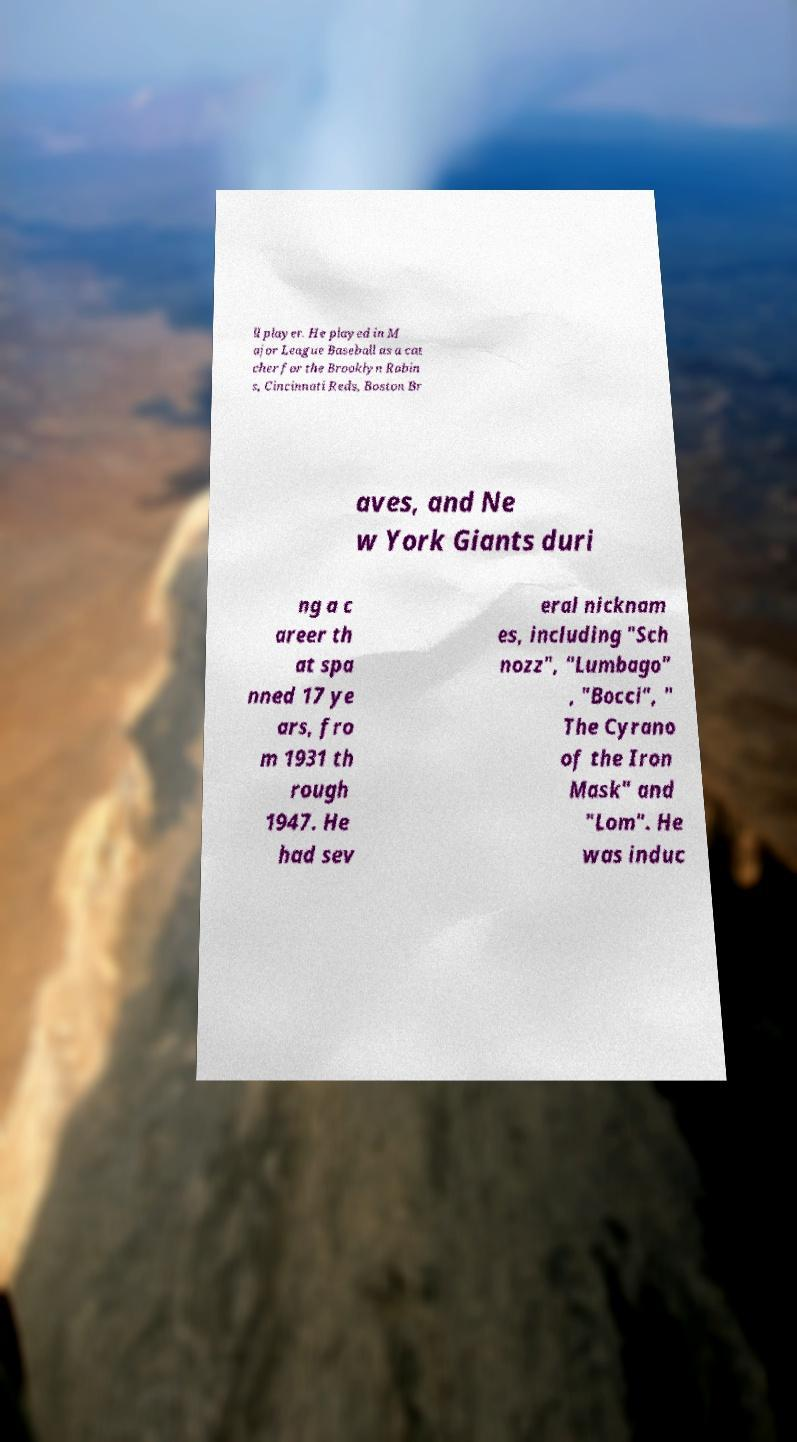Can you read and provide the text displayed in the image?This photo seems to have some interesting text. Can you extract and type it out for me? ll player. He played in M ajor League Baseball as a cat cher for the Brooklyn Robin s, Cincinnati Reds, Boston Br aves, and Ne w York Giants duri ng a c areer th at spa nned 17 ye ars, fro m 1931 th rough 1947. He had sev eral nicknam es, including "Sch nozz", "Lumbago" , "Bocci", " The Cyrano of the Iron Mask" and "Lom". He was induc 